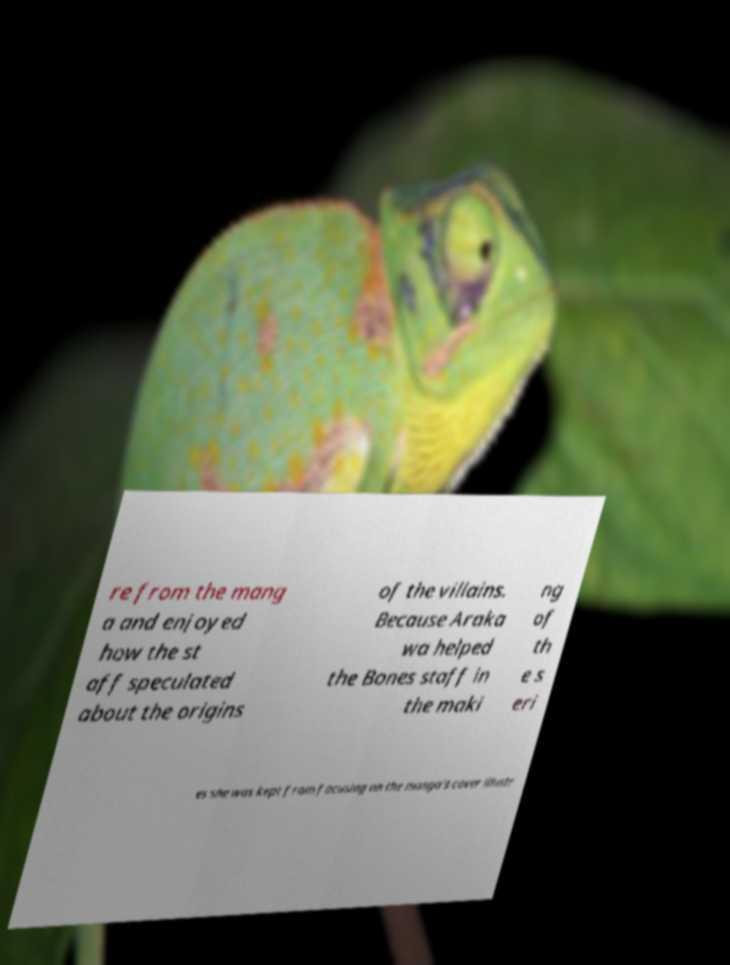Please identify and transcribe the text found in this image. re from the mang a and enjoyed how the st aff speculated about the origins of the villains. Because Araka wa helped the Bones staff in the maki ng of th e s eri es she was kept from focusing on the manga's cover illustr 